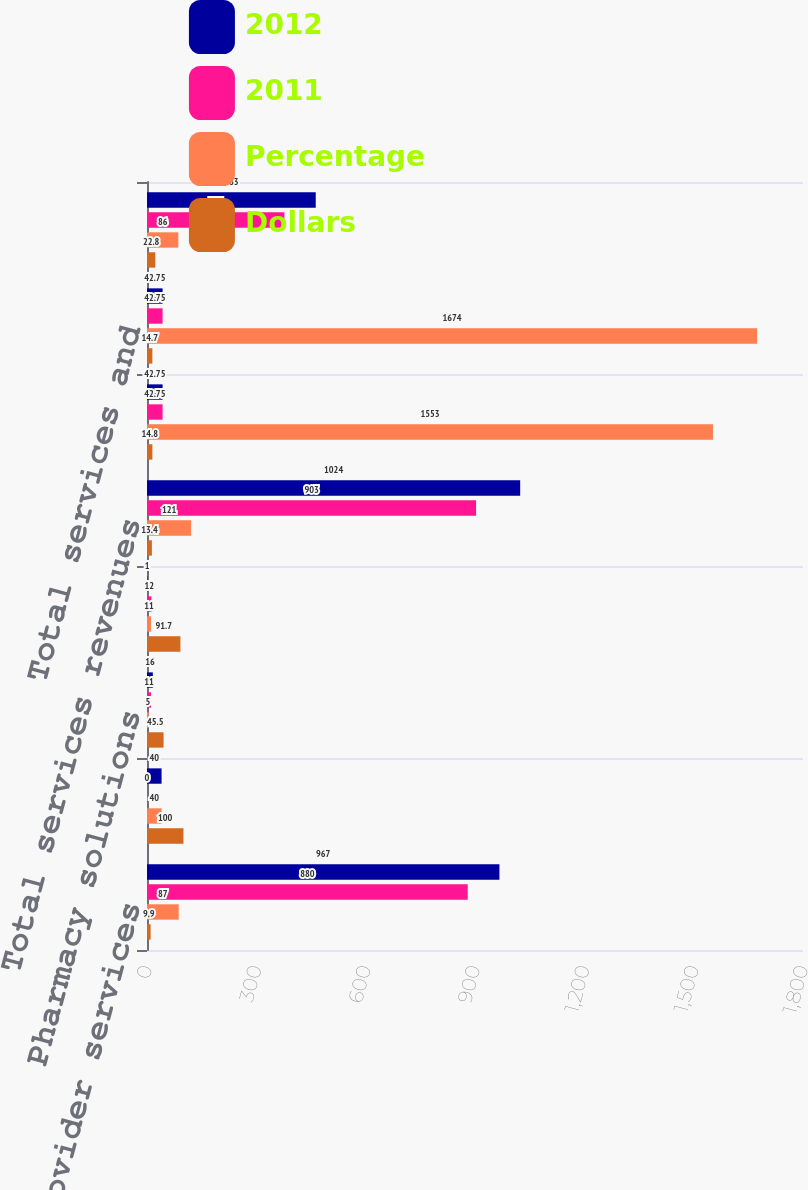<chart> <loc_0><loc_0><loc_500><loc_500><stacked_bar_chart><ecel><fcel>Provider services<fcel>Home based services<fcel>Pharmacy solutions<fcel>Integrated behavioral health<fcel>Total services revenues<fcel>Total intersegment revenues<fcel>Total services and<fcel>Income before income taxes<nl><fcel>2012<fcel>967<fcel>40<fcel>16<fcel>1<fcel>1024<fcel>42.75<fcel>42.75<fcel>463<nl><fcel>2011<fcel>880<fcel>0<fcel>11<fcel>12<fcel>903<fcel>42.75<fcel>42.75<fcel>377<nl><fcel>Percentage<fcel>87<fcel>40<fcel>5<fcel>11<fcel>121<fcel>1553<fcel>1674<fcel>86<nl><fcel>Dollars<fcel>9.9<fcel>100<fcel>45.5<fcel>91.7<fcel>13.4<fcel>14.8<fcel>14.7<fcel>22.8<nl></chart> 